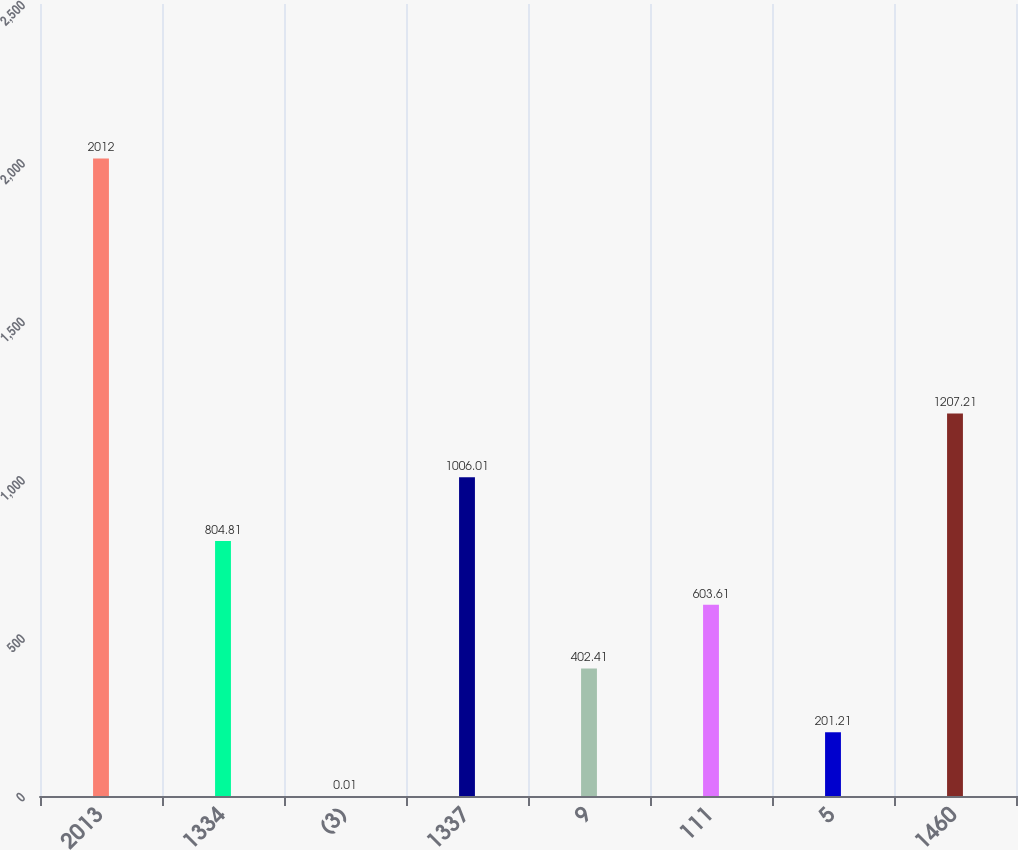<chart> <loc_0><loc_0><loc_500><loc_500><bar_chart><fcel>2013<fcel>1334<fcel>(3)<fcel>1337<fcel>9<fcel>111<fcel>5<fcel>1460<nl><fcel>2012<fcel>804.81<fcel>0.01<fcel>1006.01<fcel>402.41<fcel>603.61<fcel>201.21<fcel>1207.21<nl></chart> 